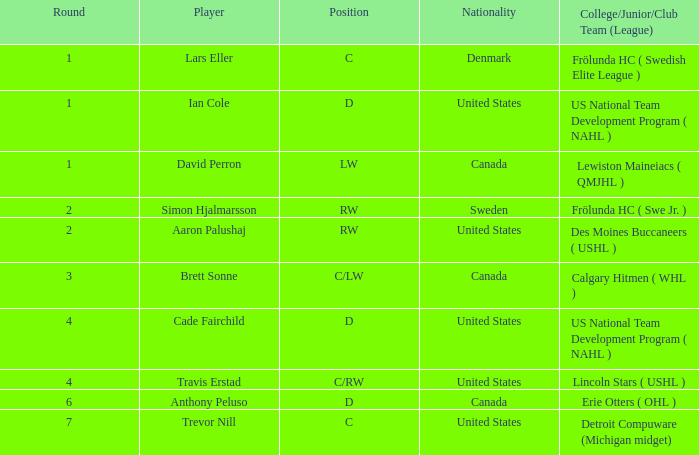What is the rank of the player from round 2 from sweden? RW. 